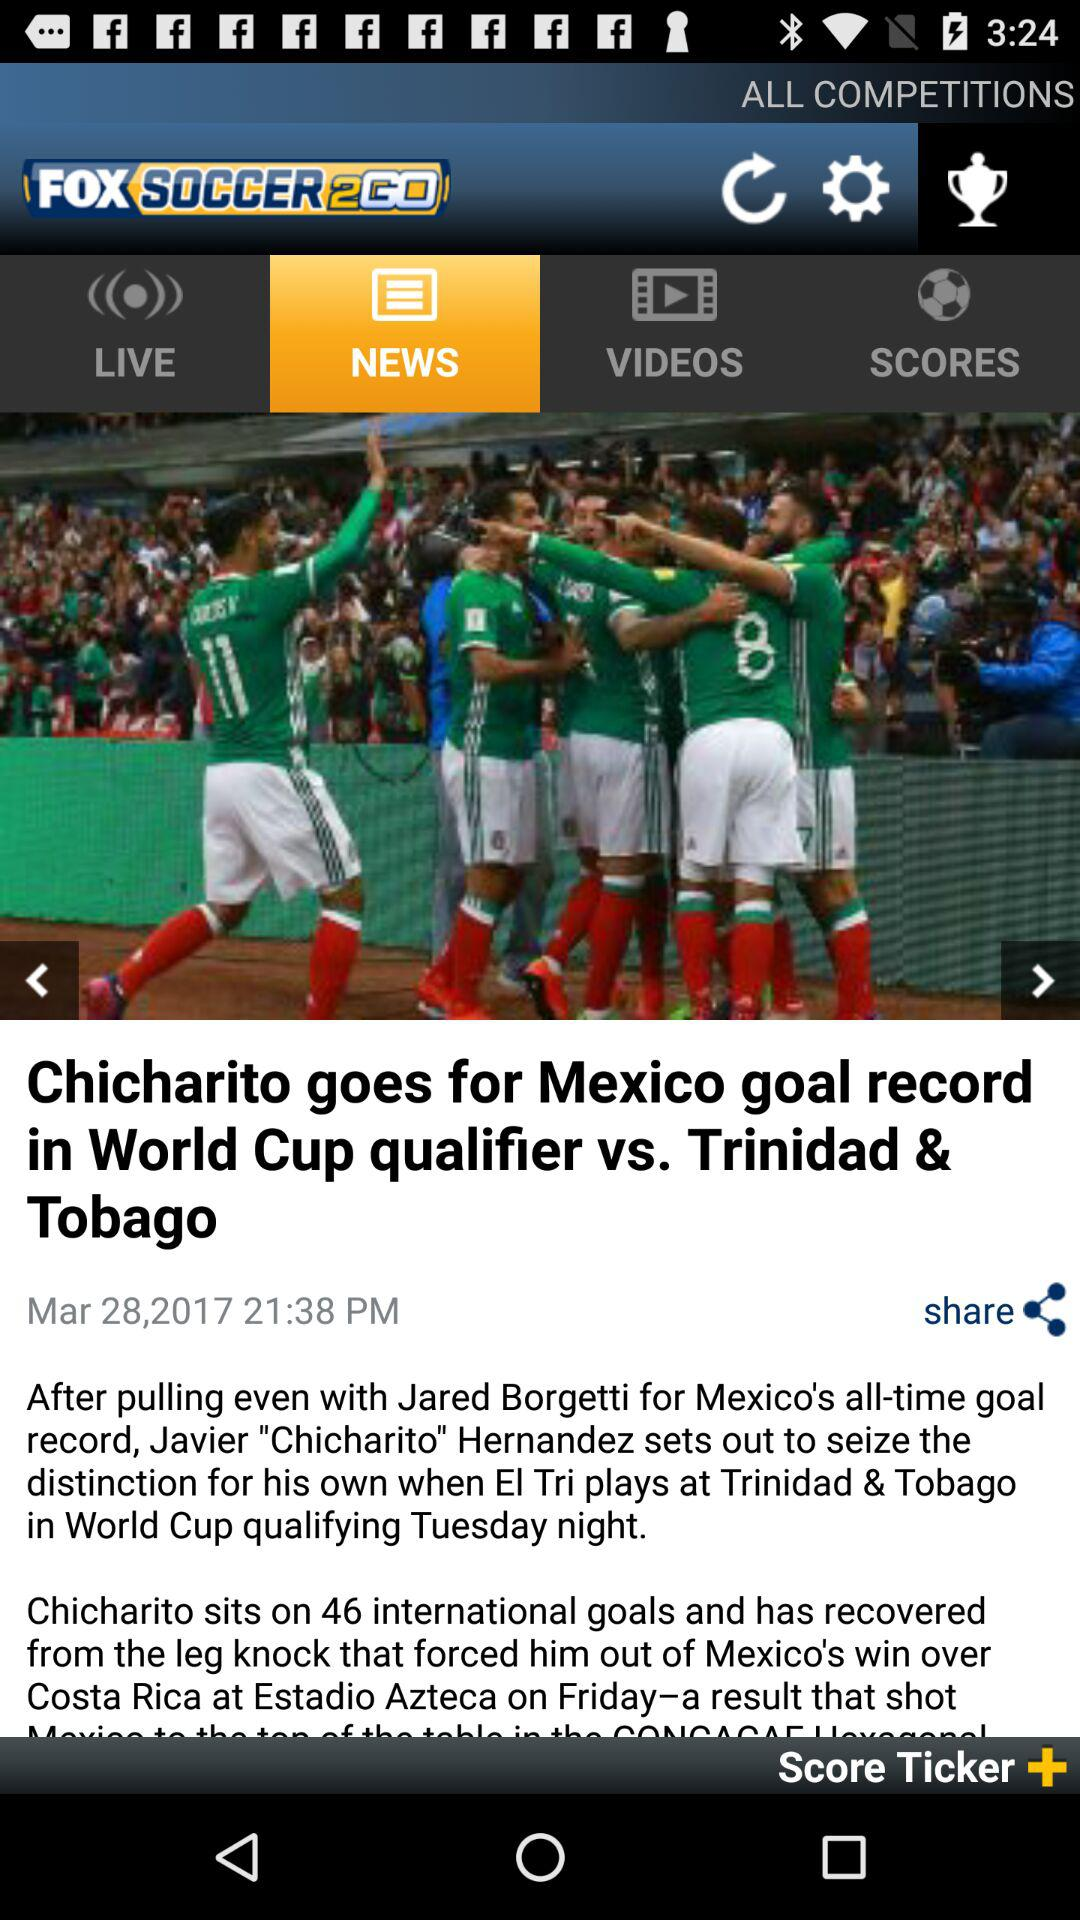What is the day for the selected date?
When the provided information is insufficient, respond with <no answer>. <no answer> 